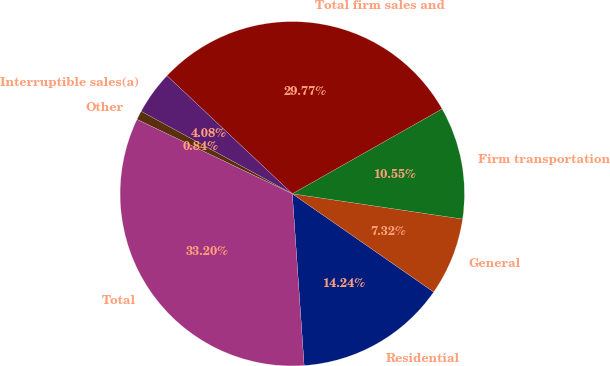<chart> <loc_0><loc_0><loc_500><loc_500><pie_chart><fcel>Residential<fcel>General<fcel>Firm transportation<fcel>Total firm sales and<fcel>Interruptible sales(a)<fcel>Other<fcel>Total<nl><fcel>14.24%<fcel>7.32%<fcel>10.55%<fcel>29.77%<fcel>4.08%<fcel>0.84%<fcel>33.2%<nl></chart> 